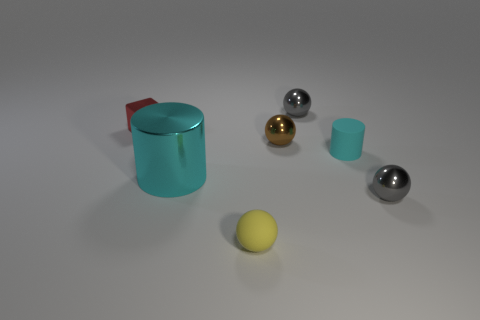Subtract all green cylinders. How many gray spheres are left? 2 Subtract all tiny yellow balls. How many balls are left? 3 Add 2 brown things. How many objects exist? 9 Subtract 1 spheres. How many spheres are left? 3 Subtract all gray balls. How many balls are left? 2 Subtract all cylinders. How many objects are left? 5 Subtract all tiny gray objects. Subtract all small red shiny blocks. How many objects are left? 4 Add 5 small cyan cylinders. How many small cyan cylinders are left? 6 Add 3 red metal things. How many red metal things exist? 4 Subtract 1 brown spheres. How many objects are left? 6 